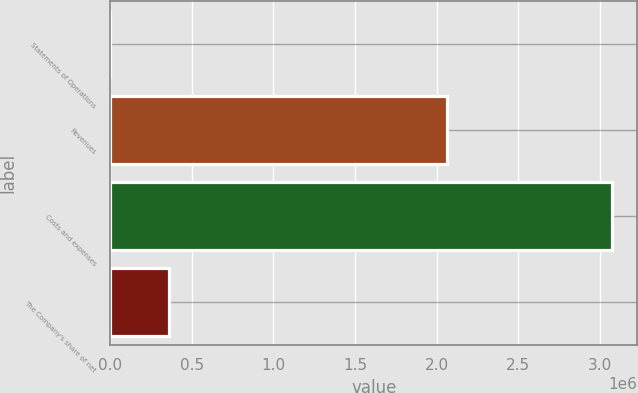Convert chart to OTSL. <chart><loc_0><loc_0><loc_500><loc_500><bar_chart><fcel>Statements of Operations<fcel>Revenues<fcel>Costs and expenses<fcel>The Company's share of net<nl><fcel>2007<fcel>2.06028e+06<fcel>3.0757e+06<fcel>362899<nl></chart> 